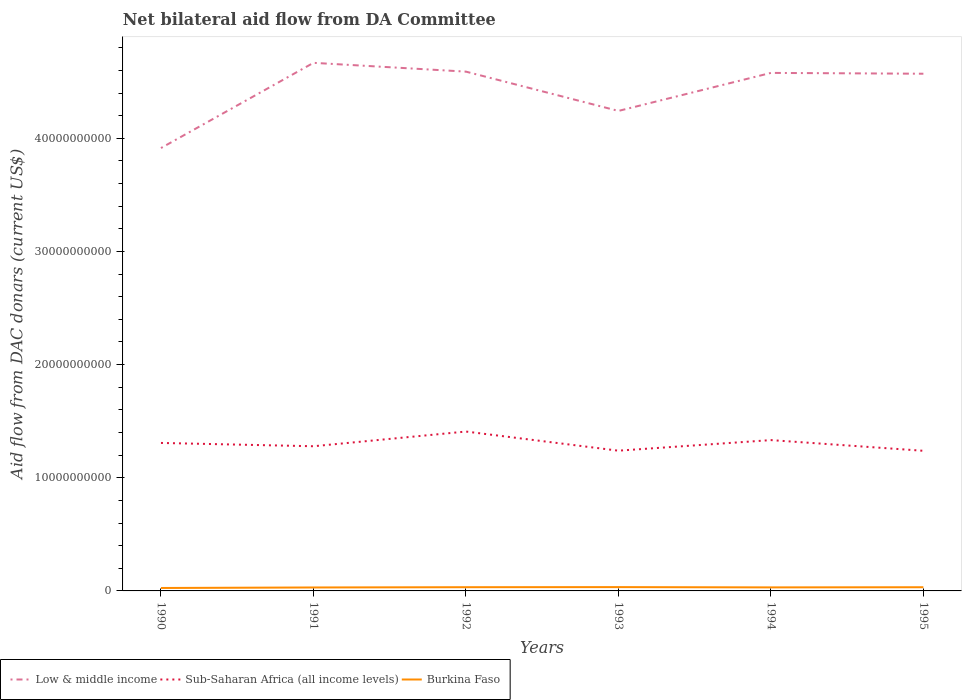Across all years, what is the maximum aid flow in in Sub-Saharan Africa (all income levels)?
Ensure brevity in your answer.  1.24e+1. What is the total aid flow in in Sub-Saharan Africa (all income levels) in the graph?
Your answer should be very brief. 1.05e+07. What is the difference between the highest and the second highest aid flow in in Low & middle income?
Keep it short and to the point. 7.53e+09. Are the values on the major ticks of Y-axis written in scientific E-notation?
Keep it short and to the point. No. Does the graph contain any zero values?
Ensure brevity in your answer.  No. How are the legend labels stacked?
Your answer should be compact. Horizontal. What is the title of the graph?
Give a very brief answer. Net bilateral aid flow from DA Committee. Does "Tanzania" appear as one of the legend labels in the graph?
Give a very brief answer. No. What is the label or title of the Y-axis?
Keep it short and to the point. Aid flow from DAC donars (current US$). What is the Aid flow from DAC donars (current US$) in Low & middle income in 1990?
Your answer should be compact. 3.91e+1. What is the Aid flow from DAC donars (current US$) of Sub-Saharan Africa (all income levels) in 1990?
Give a very brief answer. 1.31e+1. What is the Aid flow from DAC donars (current US$) in Burkina Faso in 1990?
Make the answer very short. 2.59e+08. What is the Aid flow from DAC donars (current US$) of Low & middle income in 1991?
Ensure brevity in your answer.  4.67e+1. What is the Aid flow from DAC donars (current US$) in Sub-Saharan Africa (all income levels) in 1991?
Offer a very short reply. 1.28e+1. What is the Aid flow from DAC donars (current US$) of Burkina Faso in 1991?
Provide a succinct answer. 3.05e+08. What is the Aid flow from DAC donars (current US$) in Low & middle income in 1992?
Keep it short and to the point. 4.59e+1. What is the Aid flow from DAC donars (current US$) in Sub-Saharan Africa (all income levels) in 1992?
Your answer should be compact. 1.41e+1. What is the Aid flow from DAC donars (current US$) in Burkina Faso in 1992?
Your answer should be very brief. 3.29e+08. What is the Aid flow from DAC donars (current US$) in Low & middle income in 1993?
Your response must be concise. 4.24e+1. What is the Aid flow from DAC donars (current US$) of Sub-Saharan Africa (all income levels) in 1993?
Provide a succinct answer. 1.24e+1. What is the Aid flow from DAC donars (current US$) in Burkina Faso in 1993?
Give a very brief answer. 3.37e+08. What is the Aid flow from DAC donars (current US$) in Low & middle income in 1994?
Your answer should be very brief. 4.58e+1. What is the Aid flow from DAC donars (current US$) of Sub-Saharan Africa (all income levels) in 1994?
Provide a short and direct response. 1.33e+1. What is the Aid flow from DAC donars (current US$) in Burkina Faso in 1994?
Give a very brief answer. 3.12e+08. What is the Aid flow from DAC donars (current US$) in Low & middle income in 1995?
Your response must be concise. 4.57e+1. What is the Aid flow from DAC donars (current US$) of Sub-Saharan Africa (all income levels) in 1995?
Keep it short and to the point. 1.24e+1. What is the Aid flow from DAC donars (current US$) in Burkina Faso in 1995?
Ensure brevity in your answer.  3.26e+08. Across all years, what is the maximum Aid flow from DAC donars (current US$) in Low & middle income?
Provide a short and direct response. 4.67e+1. Across all years, what is the maximum Aid flow from DAC donars (current US$) of Sub-Saharan Africa (all income levels)?
Offer a terse response. 1.41e+1. Across all years, what is the maximum Aid flow from DAC donars (current US$) in Burkina Faso?
Your response must be concise. 3.37e+08. Across all years, what is the minimum Aid flow from DAC donars (current US$) in Low & middle income?
Offer a very short reply. 3.91e+1. Across all years, what is the minimum Aid flow from DAC donars (current US$) in Sub-Saharan Africa (all income levels)?
Provide a succinct answer. 1.24e+1. Across all years, what is the minimum Aid flow from DAC donars (current US$) in Burkina Faso?
Keep it short and to the point. 2.59e+08. What is the total Aid flow from DAC donars (current US$) of Low & middle income in the graph?
Your response must be concise. 2.66e+11. What is the total Aid flow from DAC donars (current US$) of Sub-Saharan Africa (all income levels) in the graph?
Your answer should be compact. 7.81e+1. What is the total Aid flow from DAC donars (current US$) of Burkina Faso in the graph?
Offer a very short reply. 1.87e+09. What is the difference between the Aid flow from DAC donars (current US$) of Low & middle income in 1990 and that in 1991?
Give a very brief answer. -7.53e+09. What is the difference between the Aid flow from DAC donars (current US$) of Sub-Saharan Africa (all income levels) in 1990 and that in 1991?
Your response must be concise. 2.92e+08. What is the difference between the Aid flow from DAC donars (current US$) of Burkina Faso in 1990 and that in 1991?
Ensure brevity in your answer.  -4.61e+07. What is the difference between the Aid flow from DAC donars (current US$) of Low & middle income in 1990 and that in 1992?
Offer a terse response. -6.75e+09. What is the difference between the Aid flow from DAC donars (current US$) in Sub-Saharan Africa (all income levels) in 1990 and that in 1992?
Provide a short and direct response. -1.01e+09. What is the difference between the Aid flow from DAC donars (current US$) in Burkina Faso in 1990 and that in 1992?
Provide a short and direct response. -7.00e+07. What is the difference between the Aid flow from DAC donars (current US$) of Low & middle income in 1990 and that in 1993?
Offer a terse response. -3.28e+09. What is the difference between the Aid flow from DAC donars (current US$) in Sub-Saharan Africa (all income levels) in 1990 and that in 1993?
Your answer should be very brief. 6.83e+08. What is the difference between the Aid flow from DAC donars (current US$) in Burkina Faso in 1990 and that in 1993?
Offer a very short reply. -7.84e+07. What is the difference between the Aid flow from DAC donars (current US$) of Low & middle income in 1990 and that in 1994?
Make the answer very short. -6.64e+09. What is the difference between the Aid flow from DAC donars (current US$) of Sub-Saharan Africa (all income levels) in 1990 and that in 1994?
Your response must be concise. -2.52e+08. What is the difference between the Aid flow from DAC donars (current US$) of Burkina Faso in 1990 and that in 1994?
Ensure brevity in your answer.  -5.28e+07. What is the difference between the Aid flow from DAC donars (current US$) of Low & middle income in 1990 and that in 1995?
Keep it short and to the point. -6.57e+09. What is the difference between the Aid flow from DAC donars (current US$) in Sub-Saharan Africa (all income levels) in 1990 and that in 1995?
Offer a terse response. 6.94e+08. What is the difference between the Aid flow from DAC donars (current US$) in Burkina Faso in 1990 and that in 1995?
Offer a very short reply. -6.68e+07. What is the difference between the Aid flow from DAC donars (current US$) in Low & middle income in 1991 and that in 1992?
Offer a very short reply. 7.78e+08. What is the difference between the Aid flow from DAC donars (current US$) of Sub-Saharan Africa (all income levels) in 1991 and that in 1992?
Ensure brevity in your answer.  -1.30e+09. What is the difference between the Aid flow from DAC donars (current US$) in Burkina Faso in 1991 and that in 1992?
Your response must be concise. -2.39e+07. What is the difference between the Aid flow from DAC donars (current US$) of Low & middle income in 1991 and that in 1993?
Your answer should be compact. 4.25e+09. What is the difference between the Aid flow from DAC donars (current US$) in Sub-Saharan Africa (all income levels) in 1991 and that in 1993?
Your response must be concise. 3.91e+08. What is the difference between the Aid flow from DAC donars (current US$) in Burkina Faso in 1991 and that in 1993?
Give a very brief answer. -3.22e+07. What is the difference between the Aid flow from DAC donars (current US$) in Low & middle income in 1991 and that in 1994?
Offer a terse response. 8.90e+08. What is the difference between the Aid flow from DAC donars (current US$) in Sub-Saharan Africa (all income levels) in 1991 and that in 1994?
Ensure brevity in your answer.  -5.44e+08. What is the difference between the Aid flow from DAC donars (current US$) of Burkina Faso in 1991 and that in 1994?
Ensure brevity in your answer.  -6.69e+06. What is the difference between the Aid flow from DAC donars (current US$) in Low & middle income in 1991 and that in 1995?
Keep it short and to the point. 9.63e+08. What is the difference between the Aid flow from DAC donars (current US$) in Sub-Saharan Africa (all income levels) in 1991 and that in 1995?
Your answer should be compact. 4.02e+08. What is the difference between the Aid flow from DAC donars (current US$) of Burkina Faso in 1991 and that in 1995?
Provide a short and direct response. -2.07e+07. What is the difference between the Aid flow from DAC donars (current US$) of Low & middle income in 1992 and that in 1993?
Give a very brief answer. 3.47e+09. What is the difference between the Aid flow from DAC donars (current US$) of Sub-Saharan Africa (all income levels) in 1992 and that in 1993?
Provide a succinct answer. 1.69e+09. What is the difference between the Aid flow from DAC donars (current US$) in Burkina Faso in 1992 and that in 1993?
Offer a terse response. -8.37e+06. What is the difference between the Aid flow from DAC donars (current US$) of Low & middle income in 1992 and that in 1994?
Give a very brief answer. 1.12e+08. What is the difference between the Aid flow from DAC donars (current US$) of Sub-Saharan Africa (all income levels) in 1992 and that in 1994?
Make the answer very short. 7.56e+08. What is the difference between the Aid flow from DAC donars (current US$) in Burkina Faso in 1992 and that in 1994?
Provide a short and direct response. 1.72e+07. What is the difference between the Aid flow from DAC donars (current US$) in Low & middle income in 1992 and that in 1995?
Offer a terse response. 1.85e+08. What is the difference between the Aid flow from DAC donars (current US$) in Sub-Saharan Africa (all income levels) in 1992 and that in 1995?
Your answer should be very brief. 1.70e+09. What is the difference between the Aid flow from DAC donars (current US$) of Burkina Faso in 1992 and that in 1995?
Keep it short and to the point. 3.18e+06. What is the difference between the Aid flow from DAC donars (current US$) in Low & middle income in 1993 and that in 1994?
Keep it short and to the point. -3.36e+09. What is the difference between the Aid flow from DAC donars (current US$) in Sub-Saharan Africa (all income levels) in 1993 and that in 1994?
Keep it short and to the point. -9.35e+08. What is the difference between the Aid flow from DAC donars (current US$) of Burkina Faso in 1993 and that in 1994?
Offer a terse response. 2.55e+07. What is the difference between the Aid flow from DAC donars (current US$) in Low & middle income in 1993 and that in 1995?
Ensure brevity in your answer.  -3.29e+09. What is the difference between the Aid flow from DAC donars (current US$) in Sub-Saharan Africa (all income levels) in 1993 and that in 1995?
Offer a terse response. 1.05e+07. What is the difference between the Aid flow from DAC donars (current US$) of Burkina Faso in 1993 and that in 1995?
Offer a terse response. 1.16e+07. What is the difference between the Aid flow from DAC donars (current US$) of Low & middle income in 1994 and that in 1995?
Give a very brief answer. 7.27e+07. What is the difference between the Aid flow from DAC donars (current US$) of Sub-Saharan Africa (all income levels) in 1994 and that in 1995?
Offer a terse response. 9.45e+08. What is the difference between the Aid flow from DAC donars (current US$) of Burkina Faso in 1994 and that in 1995?
Ensure brevity in your answer.  -1.40e+07. What is the difference between the Aid flow from DAC donars (current US$) in Low & middle income in 1990 and the Aid flow from DAC donars (current US$) in Sub-Saharan Africa (all income levels) in 1991?
Give a very brief answer. 2.64e+1. What is the difference between the Aid flow from DAC donars (current US$) in Low & middle income in 1990 and the Aid flow from DAC donars (current US$) in Burkina Faso in 1991?
Ensure brevity in your answer.  3.88e+1. What is the difference between the Aid flow from DAC donars (current US$) of Sub-Saharan Africa (all income levels) in 1990 and the Aid flow from DAC donars (current US$) of Burkina Faso in 1991?
Ensure brevity in your answer.  1.28e+1. What is the difference between the Aid flow from DAC donars (current US$) in Low & middle income in 1990 and the Aid flow from DAC donars (current US$) in Sub-Saharan Africa (all income levels) in 1992?
Your response must be concise. 2.51e+1. What is the difference between the Aid flow from DAC donars (current US$) in Low & middle income in 1990 and the Aid flow from DAC donars (current US$) in Burkina Faso in 1992?
Offer a terse response. 3.88e+1. What is the difference between the Aid flow from DAC donars (current US$) of Sub-Saharan Africa (all income levels) in 1990 and the Aid flow from DAC donars (current US$) of Burkina Faso in 1992?
Your answer should be compact. 1.27e+1. What is the difference between the Aid flow from DAC donars (current US$) in Low & middle income in 1990 and the Aid flow from DAC donars (current US$) in Sub-Saharan Africa (all income levels) in 1993?
Offer a terse response. 2.67e+1. What is the difference between the Aid flow from DAC donars (current US$) in Low & middle income in 1990 and the Aid flow from DAC donars (current US$) in Burkina Faso in 1993?
Offer a very short reply. 3.88e+1. What is the difference between the Aid flow from DAC donars (current US$) in Sub-Saharan Africa (all income levels) in 1990 and the Aid flow from DAC donars (current US$) in Burkina Faso in 1993?
Provide a short and direct response. 1.27e+1. What is the difference between the Aid flow from DAC donars (current US$) in Low & middle income in 1990 and the Aid flow from DAC donars (current US$) in Sub-Saharan Africa (all income levels) in 1994?
Keep it short and to the point. 2.58e+1. What is the difference between the Aid flow from DAC donars (current US$) of Low & middle income in 1990 and the Aid flow from DAC donars (current US$) of Burkina Faso in 1994?
Ensure brevity in your answer.  3.88e+1. What is the difference between the Aid flow from DAC donars (current US$) in Sub-Saharan Africa (all income levels) in 1990 and the Aid flow from DAC donars (current US$) in Burkina Faso in 1994?
Give a very brief answer. 1.28e+1. What is the difference between the Aid flow from DAC donars (current US$) of Low & middle income in 1990 and the Aid flow from DAC donars (current US$) of Sub-Saharan Africa (all income levels) in 1995?
Make the answer very short. 2.68e+1. What is the difference between the Aid flow from DAC donars (current US$) of Low & middle income in 1990 and the Aid flow from DAC donars (current US$) of Burkina Faso in 1995?
Give a very brief answer. 3.88e+1. What is the difference between the Aid flow from DAC donars (current US$) in Sub-Saharan Africa (all income levels) in 1990 and the Aid flow from DAC donars (current US$) in Burkina Faso in 1995?
Make the answer very short. 1.28e+1. What is the difference between the Aid flow from DAC donars (current US$) of Low & middle income in 1991 and the Aid flow from DAC donars (current US$) of Sub-Saharan Africa (all income levels) in 1992?
Give a very brief answer. 3.26e+1. What is the difference between the Aid flow from DAC donars (current US$) in Low & middle income in 1991 and the Aid flow from DAC donars (current US$) in Burkina Faso in 1992?
Keep it short and to the point. 4.63e+1. What is the difference between the Aid flow from DAC donars (current US$) of Sub-Saharan Africa (all income levels) in 1991 and the Aid flow from DAC donars (current US$) of Burkina Faso in 1992?
Offer a terse response. 1.25e+1. What is the difference between the Aid flow from DAC donars (current US$) of Low & middle income in 1991 and the Aid flow from DAC donars (current US$) of Sub-Saharan Africa (all income levels) in 1993?
Keep it short and to the point. 3.43e+1. What is the difference between the Aid flow from DAC donars (current US$) in Low & middle income in 1991 and the Aid flow from DAC donars (current US$) in Burkina Faso in 1993?
Offer a terse response. 4.63e+1. What is the difference between the Aid flow from DAC donars (current US$) of Sub-Saharan Africa (all income levels) in 1991 and the Aid flow from DAC donars (current US$) of Burkina Faso in 1993?
Your answer should be compact. 1.24e+1. What is the difference between the Aid flow from DAC donars (current US$) of Low & middle income in 1991 and the Aid flow from DAC donars (current US$) of Sub-Saharan Africa (all income levels) in 1994?
Keep it short and to the point. 3.33e+1. What is the difference between the Aid flow from DAC donars (current US$) in Low & middle income in 1991 and the Aid flow from DAC donars (current US$) in Burkina Faso in 1994?
Make the answer very short. 4.64e+1. What is the difference between the Aid flow from DAC donars (current US$) of Sub-Saharan Africa (all income levels) in 1991 and the Aid flow from DAC donars (current US$) of Burkina Faso in 1994?
Offer a terse response. 1.25e+1. What is the difference between the Aid flow from DAC donars (current US$) of Low & middle income in 1991 and the Aid flow from DAC donars (current US$) of Sub-Saharan Africa (all income levels) in 1995?
Provide a short and direct response. 3.43e+1. What is the difference between the Aid flow from DAC donars (current US$) in Low & middle income in 1991 and the Aid flow from DAC donars (current US$) in Burkina Faso in 1995?
Your response must be concise. 4.63e+1. What is the difference between the Aid flow from DAC donars (current US$) in Sub-Saharan Africa (all income levels) in 1991 and the Aid flow from DAC donars (current US$) in Burkina Faso in 1995?
Provide a short and direct response. 1.25e+1. What is the difference between the Aid flow from DAC donars (current US$) in Low & middle income in 1992 and the Aid flow from DAC donars (current US$) in Sub-Saharan Africa (all income levels) in 1993?
Offer a very short reply. 3.35e+1. What is the difference between the Aid flow from DAC donars (current US$) of Low & middle income in 1992 and the Aid flow from DAC donars (current US$) of Burkina Faso in 1993?
Offer a very short reply. 4.56e+1. What is the difference between the Aid flow from DAC donars (current US$) in Sub-Saharan Africa (all income levels) in 1992 and the Aid flow from DAC donars (current US$) in Burkina Faso in 1993?
Your answer should be compact. 1.37e+1. What is the difference between the Aid flow from DAC donars (current US$) of Low & middle income in 1992 and the Aid flow from DAC donars (current US$) of Sub-Saharan Africa (all income levels) in 1994?
Your response must be concise. 3.26e+1. What is the difference between the Aid flow from DAC donars (current US$) of Low & middle income in 1992 and the Aid flow from DAC donars (current US$) of Burkina Faso in 1994?
Your answer should be very brief. 4.56e+1. What is the difference between the Aid flow from DAC donars (current US$) in Sub-Saharan Africa (all income levels) in 1992 and the Aid flow from DAC donars (current US$) in Burkina Faso in 1994?
Give a very brief answer. 1.38e+1. What is the difference between the Aid flow from DAC donars (current US$) in Low & middle income in 1992 and the Aid flow from DAC donars (current US$) in Sub-Saharan Africa (all income levels) in 1995?
Your answer should be very brief. 3.35e+1. What is the difference between the Aid flow from DAC donars (current US$) in Low & middle income in 1992 and the Aid flow from DAC donars (current US$) in Burkina Faso in 1995?
Offer a terse response. 4.56e+1. What is the difference between the Aid flow from DAC donars (current US$) of Sub-Saharan Africa (all income levels) in 1992 and the Aid flow from DAC donars (current US$) of Burkina Faso in 1995?
Your response must be concise. 1.38e+1. What is the difference between the Aid flow from DAC donars (current US$) in Low & middle income in 1993 and the Aid flow from DAC donars (current US$) in Sub-Saharan Africa (all income levels) in 1994?
Make the answer very short. 2.91e+1. What is the difference between the Aid flow from DAC donars (current US$) of Low & middle income in 1993 and the Aid flow from DAC donars (current US$) of Burkina Faso in 1994?
Give a very brief answer. 4.21e+1. What is the difference between the Aid flow from DAC donars (current US$) of Sub-Saharan Africa (all income levels) in 1993 and the Aid flow from DAC donars (current US$) of Burkina Faso in 1994?
Your response must be concise. 1.21e+1. What is the difference between the Aid flow from DAC donars (current US$) of Low & middle income in 1993 and the Aid flow from DAC donars (current US$) of Sub-Saharan Africa (all income levels) in 1995?
Provide a succinct answer. 3.00e+1. What is the difference between the Aid flow from DAC donars (current US$) in Low & middle income in 1993 and the Aid flow from DAC donars (current US$) in Burkina Faso in 1995?
Give a very brief answer. 4.21e+1. What is the difference between the Aid flow from DAC donars (current US$) of Sub-Saharan Africa (all income levels) in 1993 and the Aid flow from DAC donars (current US$) of Burkina Faso in 1995?
Provide a short and direct response. 1.21e+1. What is the difference between the Aid flow from DAC donars (current US$) of Low & middle income in 1994 and the Aid flow from DAC donars (current US$) of Sub-Saharan Africa (all income levels) in 1995?
Keep it short and to the point. 3.34e+1. What is the difference between the Aid flow from DAC donars (current US$) of Low & middle income in 1994 and the Aid flow from DAC donars (current US$) of Burkina Faso in 1995?
Offer a very short reply. 4.55e+1. What is the difference between the Aid flow from DAC donars (current US$) in Sub-Saharan Africa (all income levels) in 1994 and the Aid flow from DAC donars (current US$) in Burkina Faso in 1995?
Your answer should be very brief. 1.30e+1. What is the average Aid flow from DAC donars (current US$) of Low & middle income per year?
Your response must be concise. 4.43e+1. What is the average Aid flow from DAC donars (current US$) in Sub-Saharan Africa (all income levels) per year?
Provide a succinct answer. 1.30e+1. What is the average Aid flow from DAC donars (current US$) in Burkina Faso per year?
Ensure brevity in your answer.  3.11e+08. In the year 1990, what is the difference between the Aid flow from DAC donars (current US$) in Low & middle income and Aid flow from DAC donars (current US$) in Sub-Saharan Africa (all income levels)?
Your response must be concise. 2.61e+1. In the year 1990, what is the difference between the Aid flow from DAC donars (current US$) in Low & middle income and Aid flow from DAC donars (current US$) in Burkina Faso?
Your response must be concise. 3.89e+1. In the year 1990, what is the difference between the Aid flow from DAC donars (current US$) of Sub-Saharan Africa (all income levels) and Aid flow from DAC donars (current US$) of Burkina Faso?
Keep it short and to the point. 1.28e+1. In the year 1991, what is the difference between the Aid flow from DAC donars (current US$) in Low & middle income and Aid flow from DAC donars (current US$) in Sub-Saharan Africa (all income levels)?
Make the answer very short. 3.39e+1. In the year 1991, what is the difference between the Aid flow from DAC donars (current US$) of Low & middle income and Aid flow from DAC donars (current US$) of Burkina Faso?
Offer a very short reply. 4.64e+1. In the year 1991, what is the difference between the Aid flow from DAC donars (current US$) in Sub-Saharan Africa (all income levels) and Aid flow from DAC donars (current US$) in Burkina Faso?
Your response must be concise. 1.25e+1. In the year 1992, what is the difference between the Aid flow from DAC donars (current US$) of Low & middle income and Aid flow from DAC donars (current US$) of Sub-Saharan Africa (all income levels)?
Your answer should be compact. 3.18e+1. In the year 1992, what is the difference between the Aid flow from DAC donars (current US$) of Low & middle income and Aid flow from DAC donars (current US$) of Burkina Faso?
Provide a short and direct response. 4.56e+1. In the year 1992, what is the difference between the Aid flow from DAC donars (current US$) of Sub-Saharan Africa (all income levels) and Aid flow from DAC donars (current US$) of Burkina Faso?
Give a very brief answer. 1.38e+1. In the year 1993, what is the difference between the Aid flow from DAC donars (current US$) of Low & middle income and Aid flow from DAC donars (current US$) of Sub-Saharan Africa (all income levels)?
Offer a terse response. 3.00e+1. In the year 1993, what is the difference between the Aid flow from DAC donars (current US$) in Low & middle income and Aid flow from DAC donars (current US$) in Burkina Faso?
Give a very brief answer. 4.21e+1. In the year 1993, what is the difference between the Aid flow from DAC donars (current US$) of Sub-Saharan Africa (all income levels) and Aid flow from DAC donars (current US$) of Burkina Faso?
Provide a succinct answer. 1.21e+1. In the year 1994, what is the difference between the Aid flow from DAC donars (current US$) of Low & middle income and Aid flow from DAC donars (current US$) of Sub-Saharan Africa (all income levels)?
Provide a succinct answer. 3.24e+1. In the year 1994, what is the difference between the Aid flow from DAC donars (current US$) of Low & middle income and Aid flow from DAC donars (current US$) of Burkina Faso?
Keep it short and to the point. 4.55e+1. In the year 1994, what is the difference between the Aid flow from DAC donars (current US$) of Sub-Saharan Africa (all income levels) and Aid flow from DAC donars (current US$) of Burkina Faso?
Keep it short and to the point. 1.30e+1. In the year 1995, what is the difference between the Aid flow from DAC donars (current US$) of Low & middle income and Aid flow from DAC donars (current US$) of Sub-Saharan Africa (all income levels)?
Make the answer very short. 3.33e+1. In the year 1995, what is the difference between the Aid flow from DAC donars (current US$) in Low & middle income and Aid flow from DAC donars (current US$) in Burkina Faso?
Offer a very short reply. 4.54e+1. In the year 1995, what is the difference between the Aid flow from DAC donars (current US$) in Sub-Saharan Africa (all income levels) and Aid flow from DAC donars (current US$) in Burkina Faso?
Keep it short and to the point. 1.21e+1. What is the ratio of the Aid flow from DAC donars (current US$) of Low & middle income in 1990 to that in 1991?
Give a very brief answer. 0.84. What is the ratio of the Aid flow from DAC donars (current US$) of Sub-Saharan Africa (all income levels) in 1990 to that in 1991?
Provide a succinct answer. 1.02. What is the ratio of the Aid flow from DAC donars (current US$) in Burkina Faso in 1990 to that in 1991?
Provide a short and direct response. 0.85. What is the ratio of the Aid flow from DAC donars (current US$) of Low & middle income in 1990 to that in 1992?
Offer a very short reply. 0.85. What is the ratio of the Aid flow from DAC donars (current US$) in Sub-Saharan Africa (all income levels) in 1990 to that in 1992?
Your response must be concise. 0.93. What is the ratio of the Aid flow from DAC donars (current US$) of Burkina Faso in 1990 to that in 1992?
Your answer should be compact. 0.79. What is the ratio of the Aid flow from DAC donars (current US$) in Low & middle income in 1990 to that in 1993?
Make the answer very short. 0.92. What is the ratio of the Aid flow from DAC donars (current US$) in Sub-Saharan Africa (all income levels) in 1990 to that in 1993?
Ensure brevity in your answer.  1.06. What is the ratio of the Aid flow from DAC donars (current US$) of Burkina Faso in 1990 to that in 1993?
Keep it short and to the point. 0.77. What is the ratio of the Aid flow from DAC donars (current US$) in Low & middle income in 1990 to that in 1994?
Your response must be concise. 0.85. What is the ratio of the Aid flow from DAC donars (current US$) of Sub-Saharan Africa (all income levels) in 1990 to that in 1994?
Offer a terse response. 0.98. What is the ratio of the Aid flow from DAC donars (current US$) in Burkina Faso in 1990 to that in 1994?
Provide a short and direct response. 0.83. What is the ratio of the Aid flow from DAC donars (current US$) of Low & middle income in 1990 to that in 1995?
Provide a succinct answer. 0.86. What is the ratio of the Aid flow from DAC donars (current US$) in Sub-Saharan Africa (all income levels) in 1990 to that in 1995?
Give a very brief answer. 1.06. What is the ratio of the Aid flow from DAC donars (current US$) in Burkina Faso in 1990 to that in 1995?
Give a very brief answer. 0.79. What is the ratio of the Aid flow from DAC donars (current US$) of Low & middle income in 1991 to that in 1992?
Offer a very short reply. 1.02. What is the ratio of the Aid flow from DAC donars (current US$) of Sub-Saharan Africa (all income levels) in 1991 to that in 1992?
Make the answer very short. 0.91. What is the ratio of the Aid flow from DAC donars (current US$) in Burkina Faso in 1991 to that in 1992?
Give a very brief answer. 0.93. What is the ratio of the Aid flow from DAC donars (current US$) of Low & middle income in 1991 to that in 1993?
Offer a very short reply. 1.1. What is the ratio of the Aid flow from DAC donars (current US$) in Sub-Saharan Africa (all income levels) in 1991 to that in 1993?
Your answer should be very brief. 1.03. What is the ratio of the Aid flow from DAC donars (current US$) in Burkina Faso in 1991 to that in 1993?
Offer a very short reply. 0.9. What is the ratio of the Aid flow from DAC donars (current US$) in Low & middle income in 1991 to that in 1994?
Your answer should be very brief. 1.02. What is the ratio of the Aid flow from DAC donars (current US$) of Sub-Saharan Africa (all income levels) in 1991 to that in 1994?
Your response must be concise. 0.96. What is the ratio of the Aid flow from DAC donars (current US$) in Burkina Faso in 1991 to that in 1994?
Give a very brief answer. 0.98. What is the ratio of the Aid flow from DAC donars (current US$) in Low & middle income in 1991 to that in 1995?
Offer a terse response. 1.02. What is the ratio of the Aid flow from DAC donars (current US$) of Sub-Saharan Africa (all income levels) in 1991 to that in 1995?
Offer a terse response. 1.03. What is the ratio of the Aid flow from DAC donars (current US$) of Burkina Faso in 1991 to that in 1995?
Give a very brief answer. 0.94. What is the ratio of the Aid flow from DAC donars (current US$) of Low & middle income in 1992 to that in 1993?
Make the answer very short. 1.08. What is the ratio of the Aid flow from DAC donars (current US$) in Sub-Saharan Africa (all income levels) in 1992 to that in 1993?
Your answer should be compact. 1.14. What is the ratio of the Aid flow from DAC donars (current US$) in Burkina Faso in 1992 to that in 1993?
Your response must be concise. 0.98. What is the ratio of the Aid flow from DAC donars (current US$) of Low & middle income in 1992 to that in 1994?
Your answer should be very brief. 1. What is the ratio of the Aid flow from DAC donars (current US$) of Sub-Saharan Africa (all income levels) in 1992 to that in 1994?
Your answer should be very brief. 1.06. What is the ratio of the Aid flow from DAC donars (current US$) in Burkina Faso in 1992 to that in 1994?
Your response must be concise. 1.06. What is the ratio of the Aid flow from DAC donars (current US$) in Sub-Saharan Africa (all income levels) in 1992 to that in 1995?
Provide a succinct answer. 1.14. What is the ratio of the Aid flow from DAC donars (current US$) of Burkina Faso in 1992 to that in 1995?
Provide a short and direct response. 1.01. What is the ratio of the Aid flow from DAC donars (current US$) of Low & middle income in 1993 to that in 1994?
Provide a short and direct response. 0.93. What is the ratio of the Aid flow from DAC donars (current US$) of Sub-Saharan Africa (all income levels) in 1993 to that in 1994?
Ensure brevity in your answer.  0.93. What is the ratio of the Aid flow from DAC donars (current US$) in Burkina Faso in 1993 to that in 1994?
Provide a succinct answer. 1.08. What is the ratio of the Aid flow from DAC donars (current US$) in Low & middle income in 1993 to that in 1995?
Offer a terse response. 0.93. What is the ratio of the Aid flow from DAC donars (current US$) of Sub-Saharan Africa (all income levels) in 1993 to that in 1995?
Your answer should be compact. 1. What is the ratio of the Aid flow from DAC donars (current US$) of Burkina Faso in 1993 to that in 1995?
Your answer should be very brief. 1.04. What is the ratio of the Aid flow from DAC donars (current US$) of Low & middle income in 1994 to that in 1995?
Offer a very short reply. 1. What is the ratio of the Aid flow from DAC donars (current US$) of Sub-Saharan Africa (all income levels) in 1994 to that in 1995?
Offer a terse response. 1.08. What is the ratio of the Aid flow from DAC donars (current US$) of Burkina Faso in 1994 to that in 1995?
Your answer should be compact. 0.96. What is the difference between the highest and the second highest Aid flow from DAC donars (current US$) of Low & middle income?
Make the answer very short. 7.78e+08. What is the difference between the highest and the second highest Aid flow from DAC donars (current US$) in Sub-Saharan Africa (all income levels)?
Your answer should be compact. 7.56e+08. What is the difference between the highest and the second highest Aid flow from DAC donars (current US$) of Burkina Faso?
Make the answer very short. 8.37e+06. What is the difference between the highest and the lowest Aid flow from DAC donars (current US$) in Low & middle income?
Keep it short and to the point. 7.53e+09. What is the difference between the highest and the lowest Aid flow from DAC donars (current US$) of Sub-Saharan Africa (all income levels)?
Your answer should be very brief. 1.70e+09. What is the difference between the highest and the lowest Aid flow from DAC donars (current US$) in Burkina Faso?
Your response must be concise. 7.84e+07. 